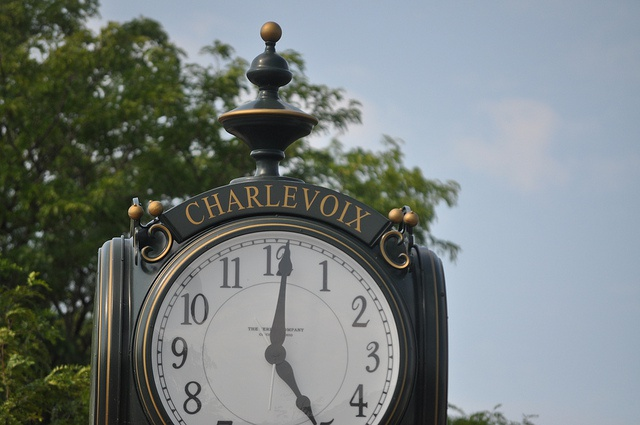Describe the objects in this image and their specific colors. I can see a clock in black, darkgray, gray, and lightgray tones in this image. 